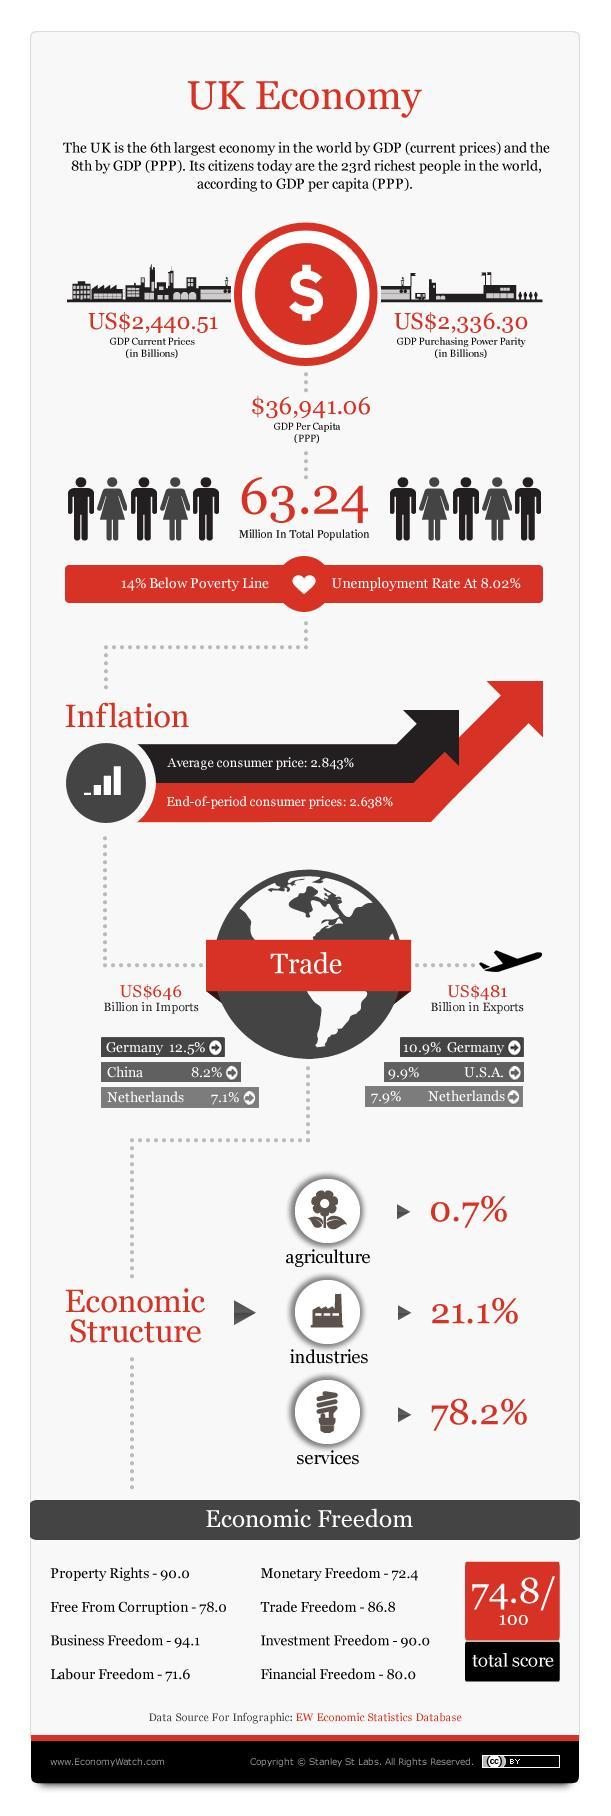What is the GDP purchasing power parity (in Billions) in UK?
Answer the question with a short phrase. US$2,336.30 What is the value of UK exports in billions? US$481 What percentage of UK imports are from Netherlands? 7.1% What percentage of UK exports go to Germany? 10.9% What percentage of UK imports are from China? 8.2% What percentage of UK exports go to USA? 9.9% What percentage does industries contribute to the UK's GDP? 21.1% Which sector contributes the most to UK's GDP? services Which sector contributes the least to UK's GDP? agriculture What is the value of UK imports in billions? US$646 